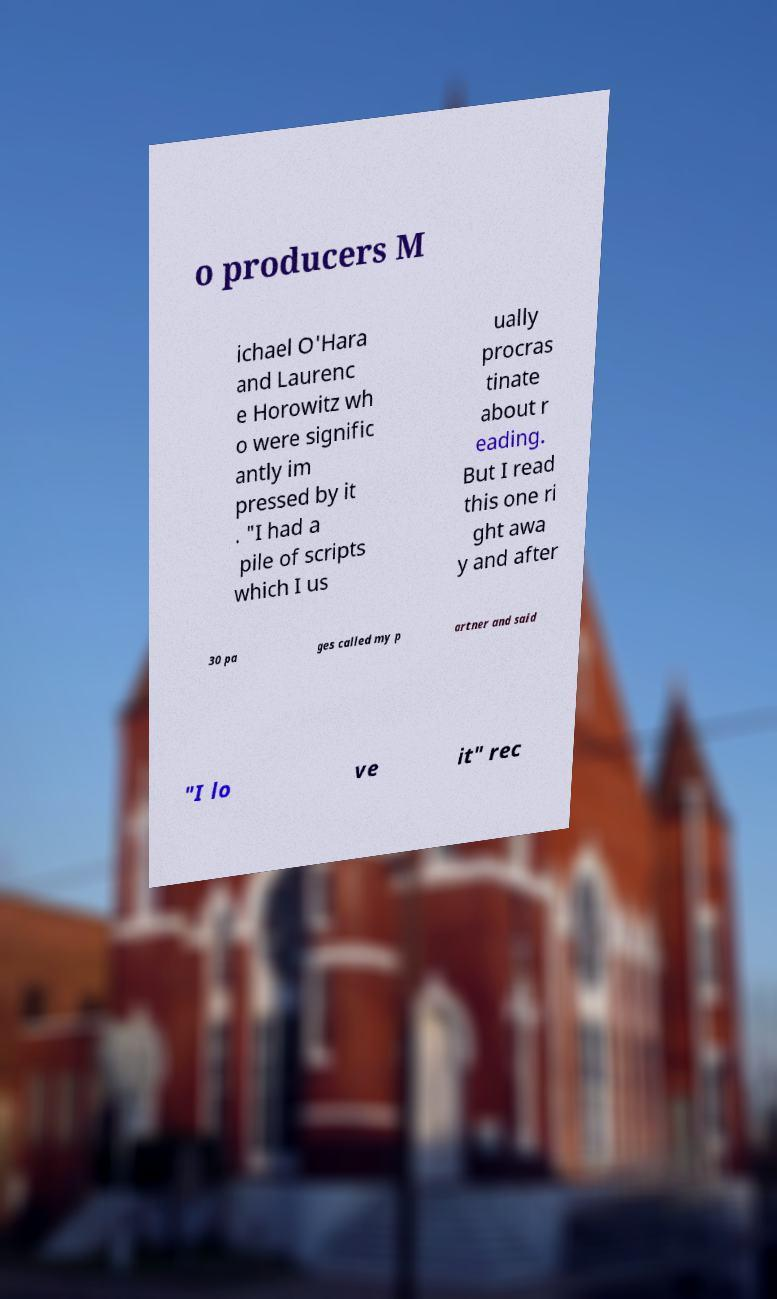Could you extract and type out the text from this image? o producers M ichael O'Hara and Laurenc e Horowitz wh o were signific antly im pressed by it . "I had a pile of scripts which I us ually procras tinate about r eading. But I read this one ri ght awa y and after 30 pa ges called my p artner and said "I lo ve it" rec 